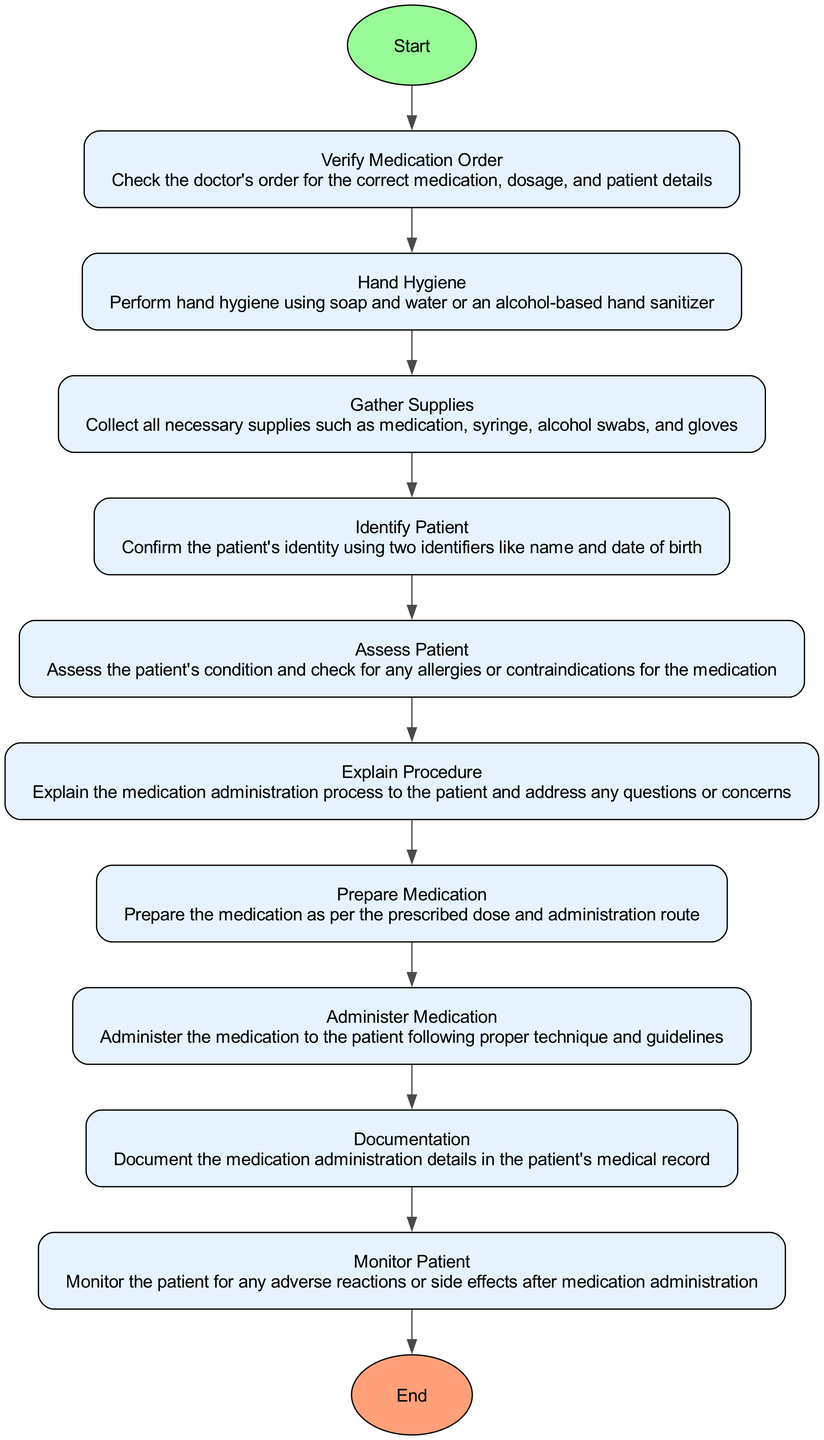What is the first step in the medication administration workflow? The first step is always the start node labeled "Start," which signifies the beginning of the process.
Answer: Start How many process steps are there in the workflow? By counting the number of process nodes, we find that there are eight steps between the start and end.
Answer: Eight What happens after verifying the medication order? After verifying the medication order, the next step is to perform hand hygiene.
Answer: Hand Hygiene What do you need to confirm the patient's identity? The patient's identity should be confirmed using two identifiers, such as name and date of birth.
Answer: Two identifiers What should you do after preparing the medication? After preparing the medication, the next action is to administer the medication to the patient.
Answer: Administer Medication Which step follows monitoring the patient? There are no steps that follow monitoring the patient; it is one of the last processes before ending.
Answer: End What type of hygiene is emphasized in the workflow? The workflow emphasizes hand hygiene, which is critical before any interaction with the patient.
Answer: Hand Hygiene What is documented after the medication is administered? The details of the medication administration must be documented in the patient's medical record.
Answer: Documentation What is the last step in the workflow? The last step in the medication administration process is labeled "End," indicating the process completion.
Answer: End 